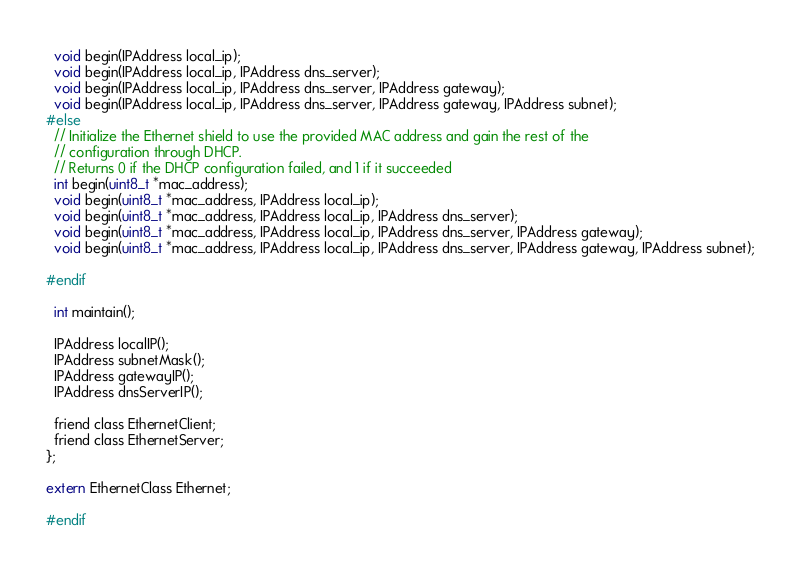Convert code to text. <code><loc_0><loc_0><loc_500><loc_500><_C_>  void begin(IPAddress local_ip);
  void begin(IPAddress local_ip, IPAddress dns_server);
  void begin(IPAddress local_ip, IPAddress dns_server, IPAddress gateway);
  void begin(IPAddress local_ip, IPAddress dns_server, IPAddress gateway, IPAddress subnet);
#else
  // Initialize the Ethernet shield to use the provided MAC address and gain the rest of the
  // configuration through DHCP.
  // Returns 0 if the DHCP configuration failed, and 1 if it succeeded
  int begin(uint8_t *mac_address);
  void begin(uint8_t *mac_address, IPAddress local_ip);
  void begin(uint8_t *mac_address, IPAddress local_ip, IPAddress dns_server);
  void begin(uint8_t *mac_address, IPAddress local_ip, IPAddress dns_server, IPAddress gateway);
  void begin(uint8_t *mac_address, IPAddress local_ip, IPAddress dns_server, IPAddress gateway, IPAddress subnet);

#endif
  
  int maintain();

  IPAddress localIP();
  IPAddress subnetMask();
  IPAddress gatewayIP();
  IPAddress dnsServerIP();

  friend class EthernetClient;
  friend class EthernetServer;
};

extern EthernetClass Ethernet;

#endif
</code> 